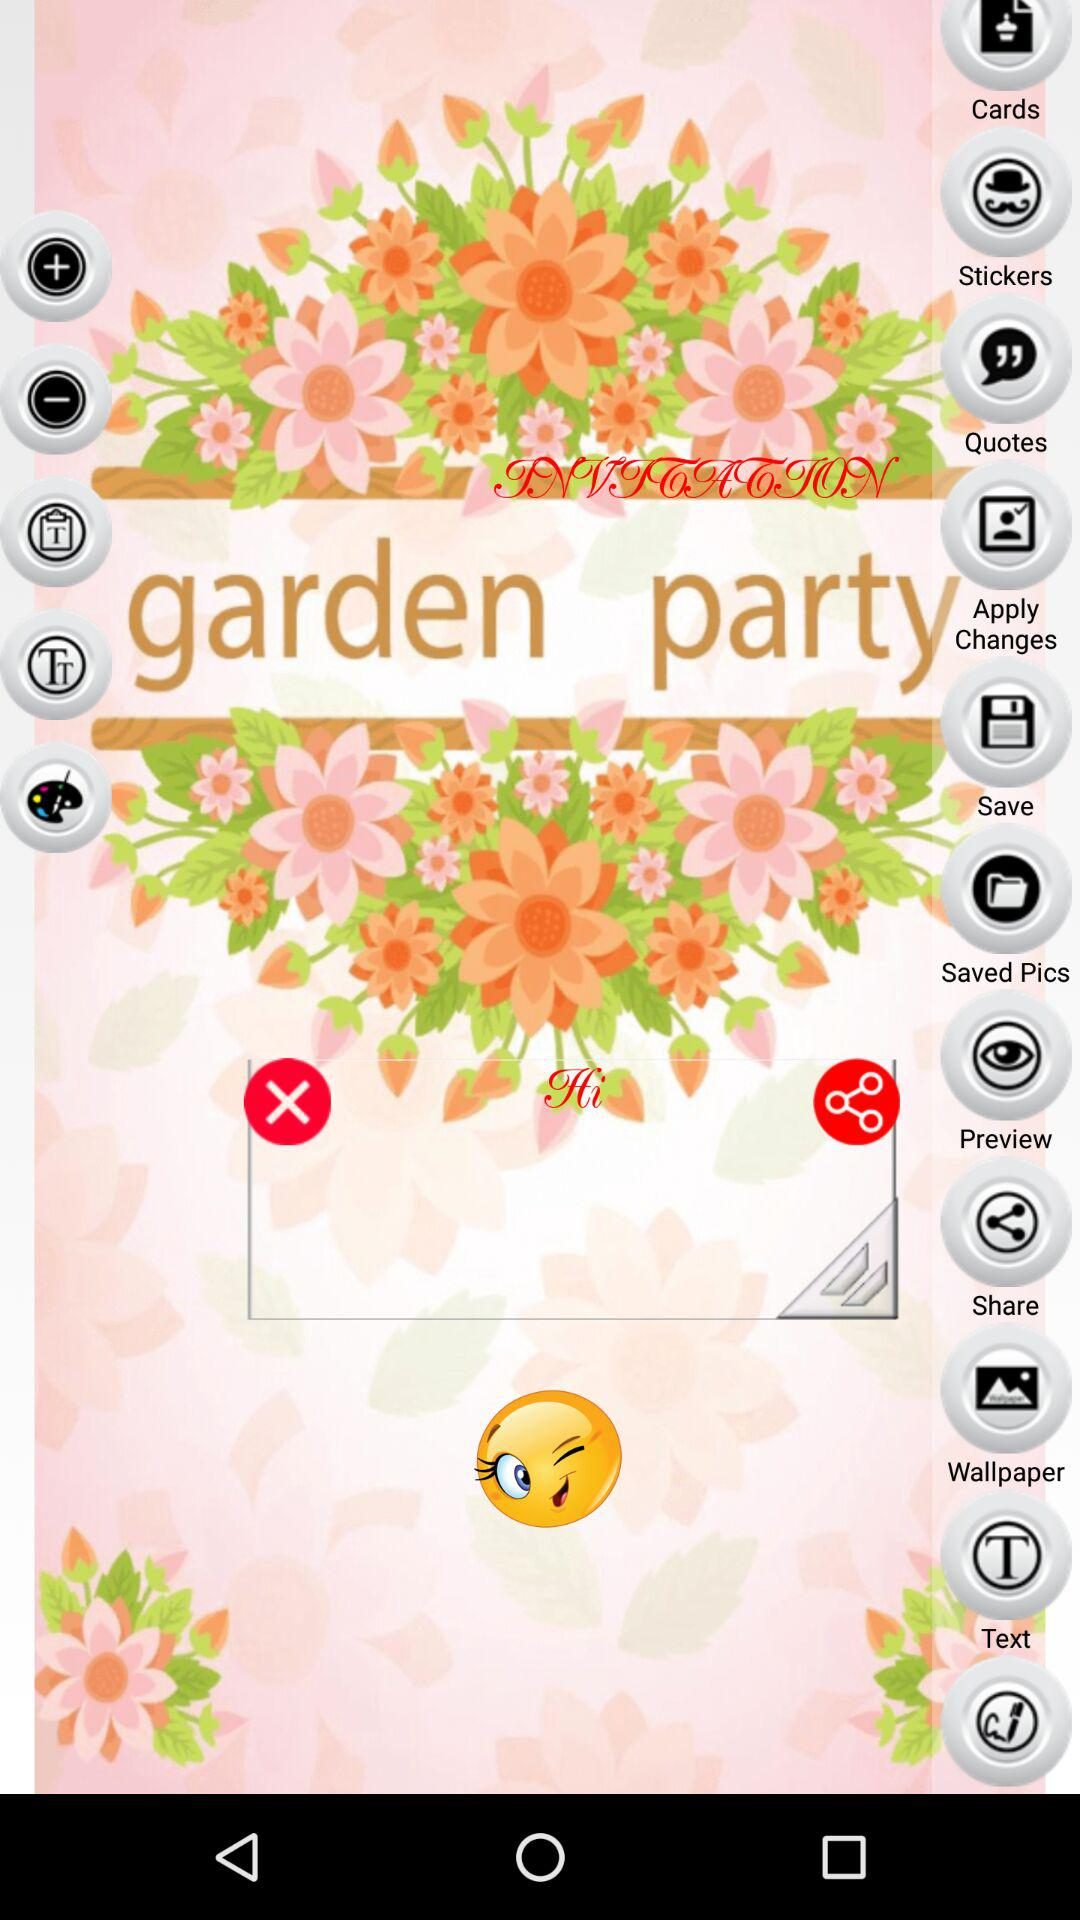What is the application name?
When the provided information is insufficient, respond with <no answer>. <no answer> 